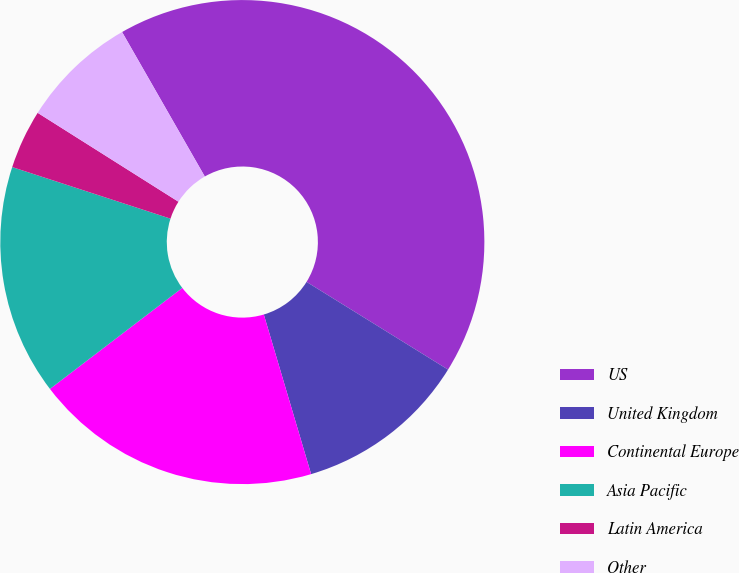<chart> <loc_0><loc_0><loc_500><loc_500><pie_chart><fcel>US<fcel>United Kingdom<fcel>Continental Europe<fcel>Asia Pacific<fcel>Latin America<fcel>Other<nl><fcel>42.11%<fcel>11.58%<fcel>19.21%<fcel>15.39%<fcel>3.95%<fcel>7.76%<nl></chart> 